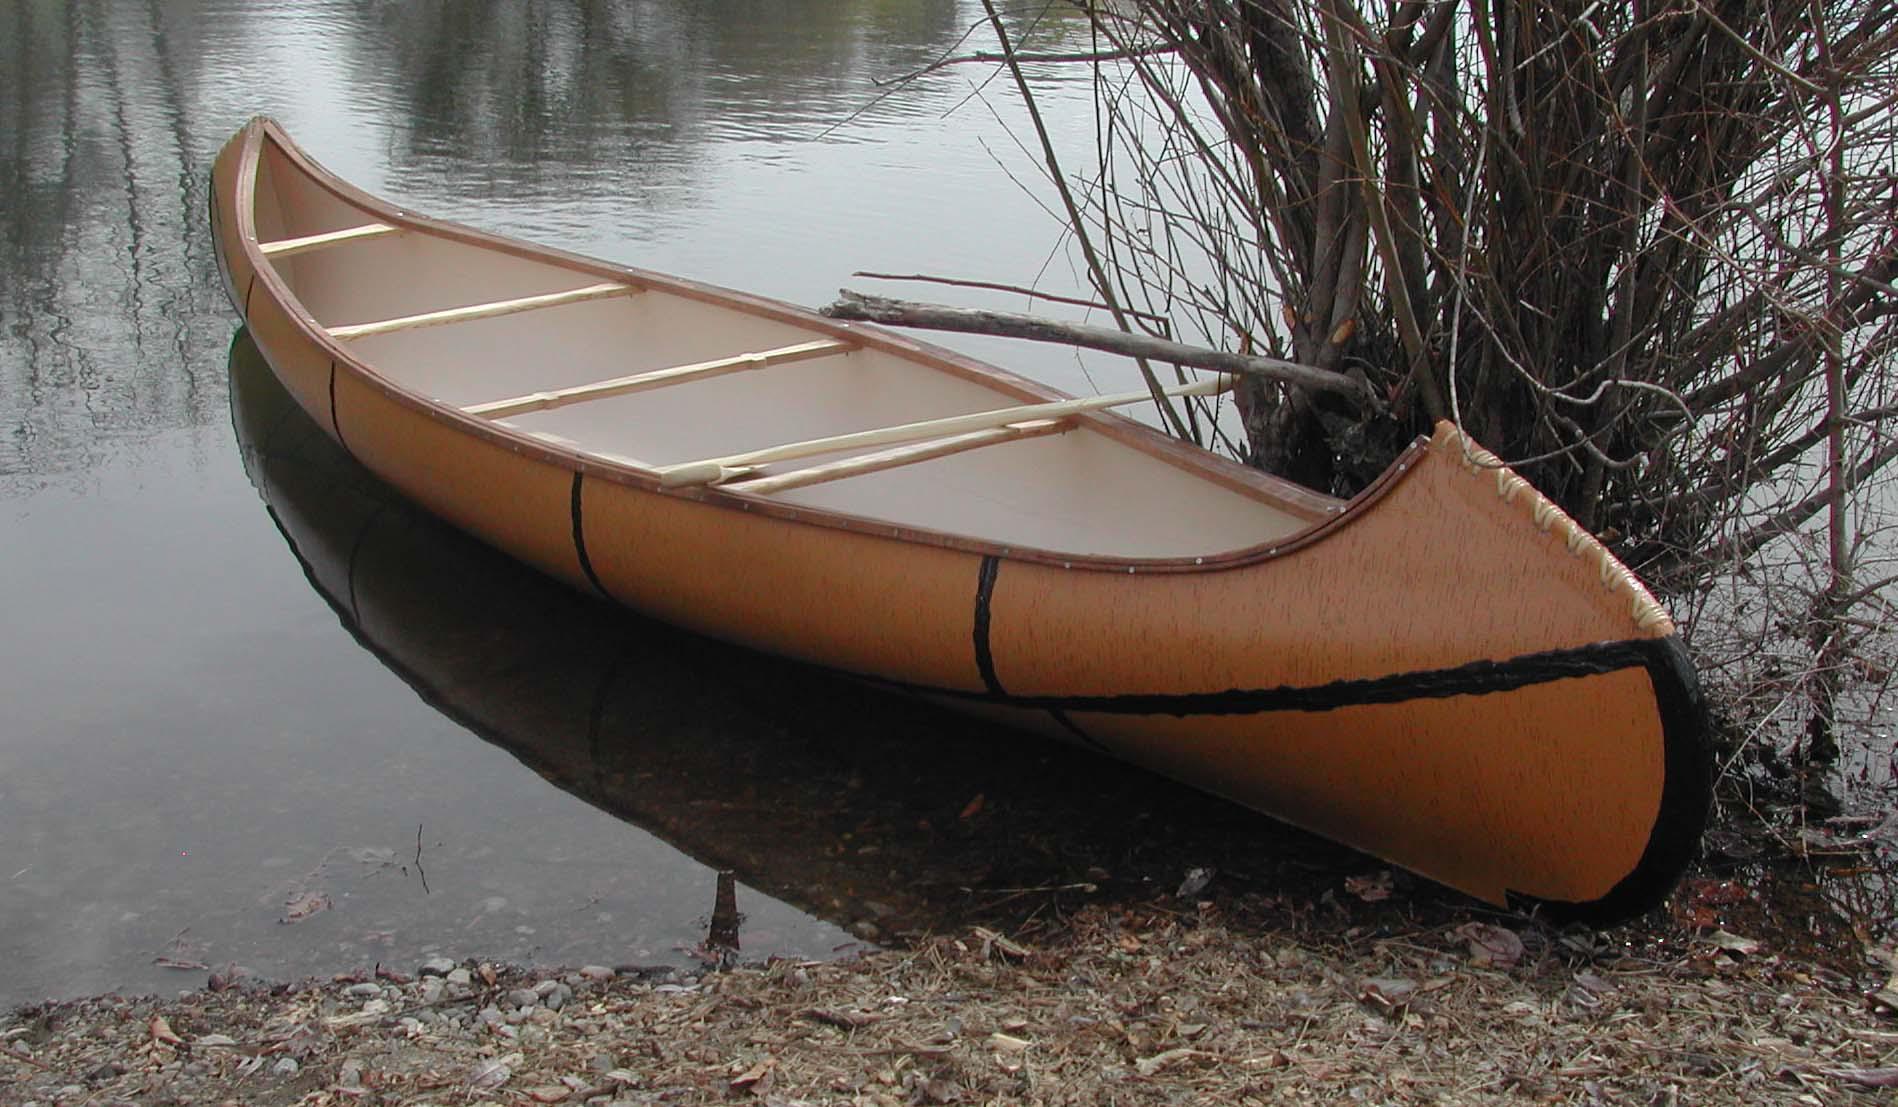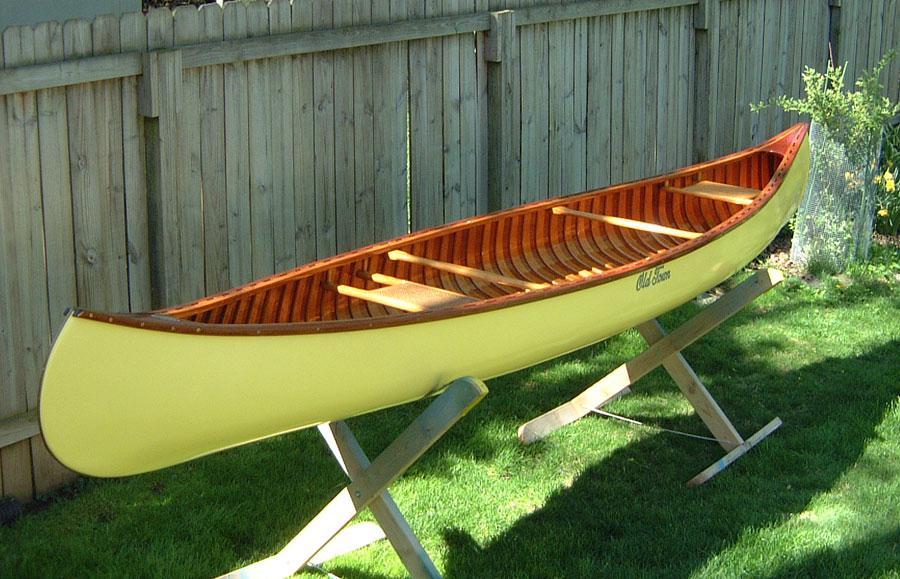The first image is the image on the left, the second image is the image on the right. Evaluate the accuracy of this statement regarding the images: "An image shows one canoe pulled up to the edge of a body of water.". Is it true? Answer yes or no. Yes. 